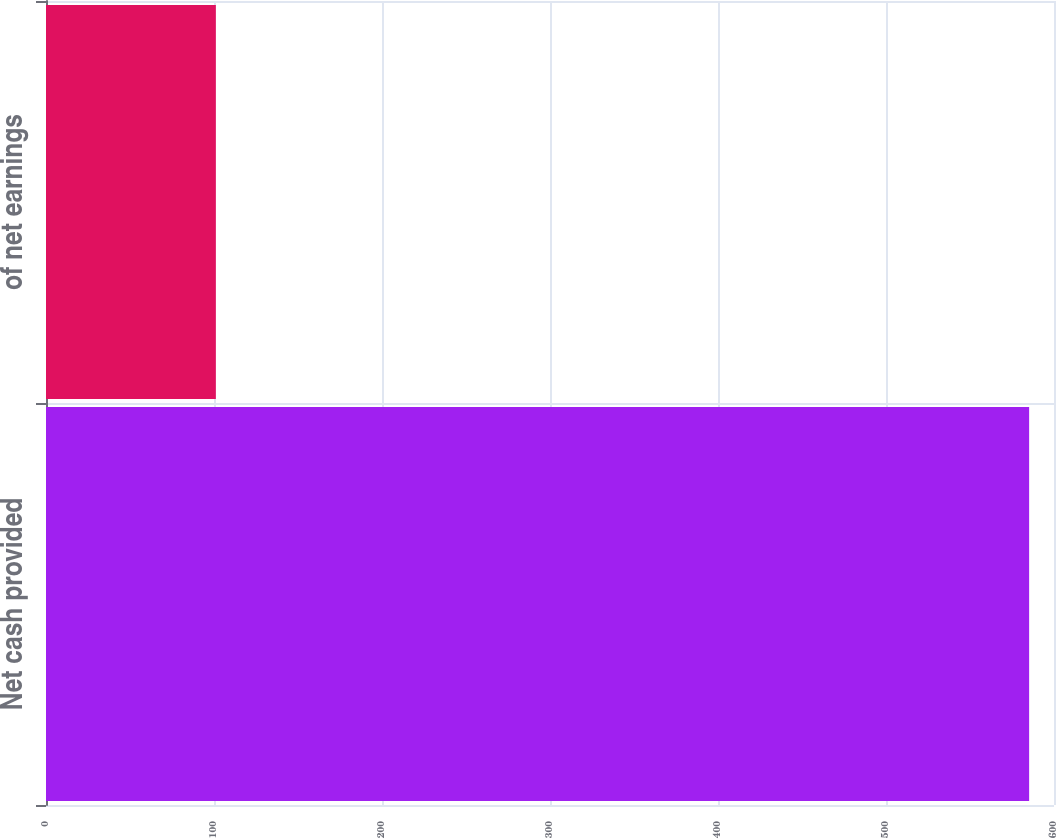<chart> <loc_0><loc_0><loc_500><loc_500><bar_chart><fcel>Net cash provided<fcel>of net earnings<nl><fcel>585.2<fcel>101.1<nl></chart> 